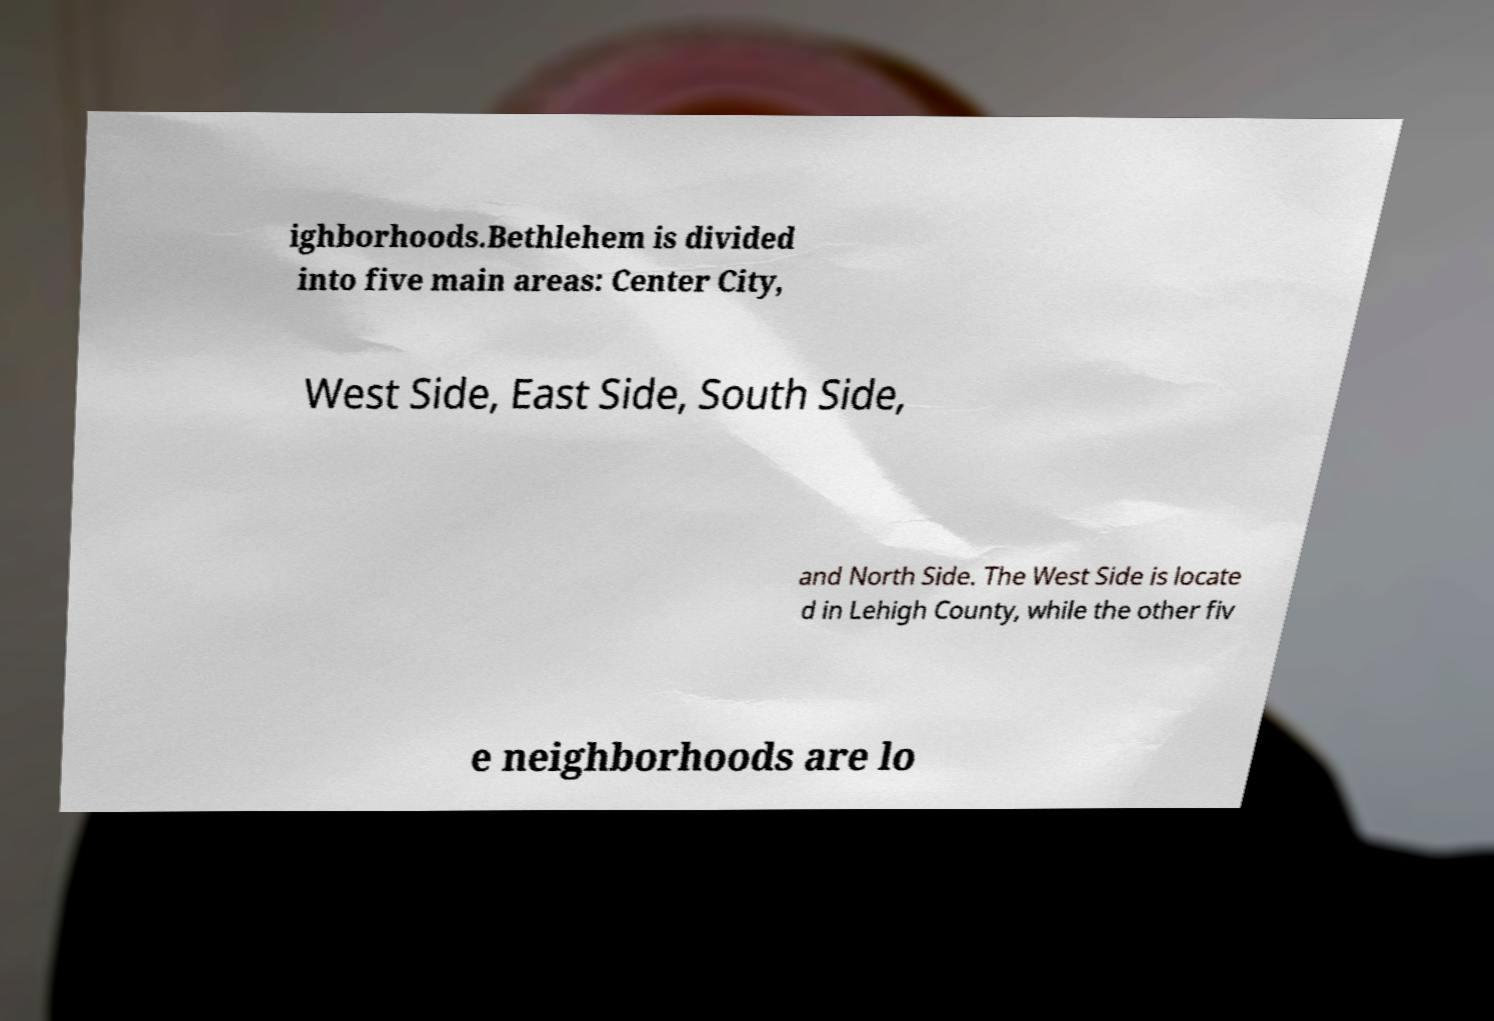Could you extract and type out the text from this image? ighborhoods.Bethlehem is divided into five main areas: Center City, West Side, East Side, South Side, and North Side. The West Side is locate d in Lehigh County, while the other fiv e neighborhoods are lo 